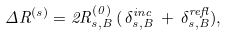<formula> <loc_0><loc_0><loc_500><loc_500>\Delta R ^ { ( s ) } = 2 R ^ { ( 0 ) } _ { s , B } \, ( \, \delta ^ { i n c } _ { s , B } \, + \, \delta ^ { r e f l } _ { s , B } ) ,</formula> 